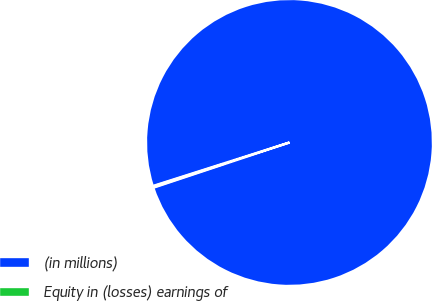Convert chart. <chart><loc_0><loc_0><loc_500><loc_500><pie_chart><fcel>(in millions)<fcel>Equity in (losses) earnings of<nl><fcel>99.8%<fcel>0.2%<nl></chart> 